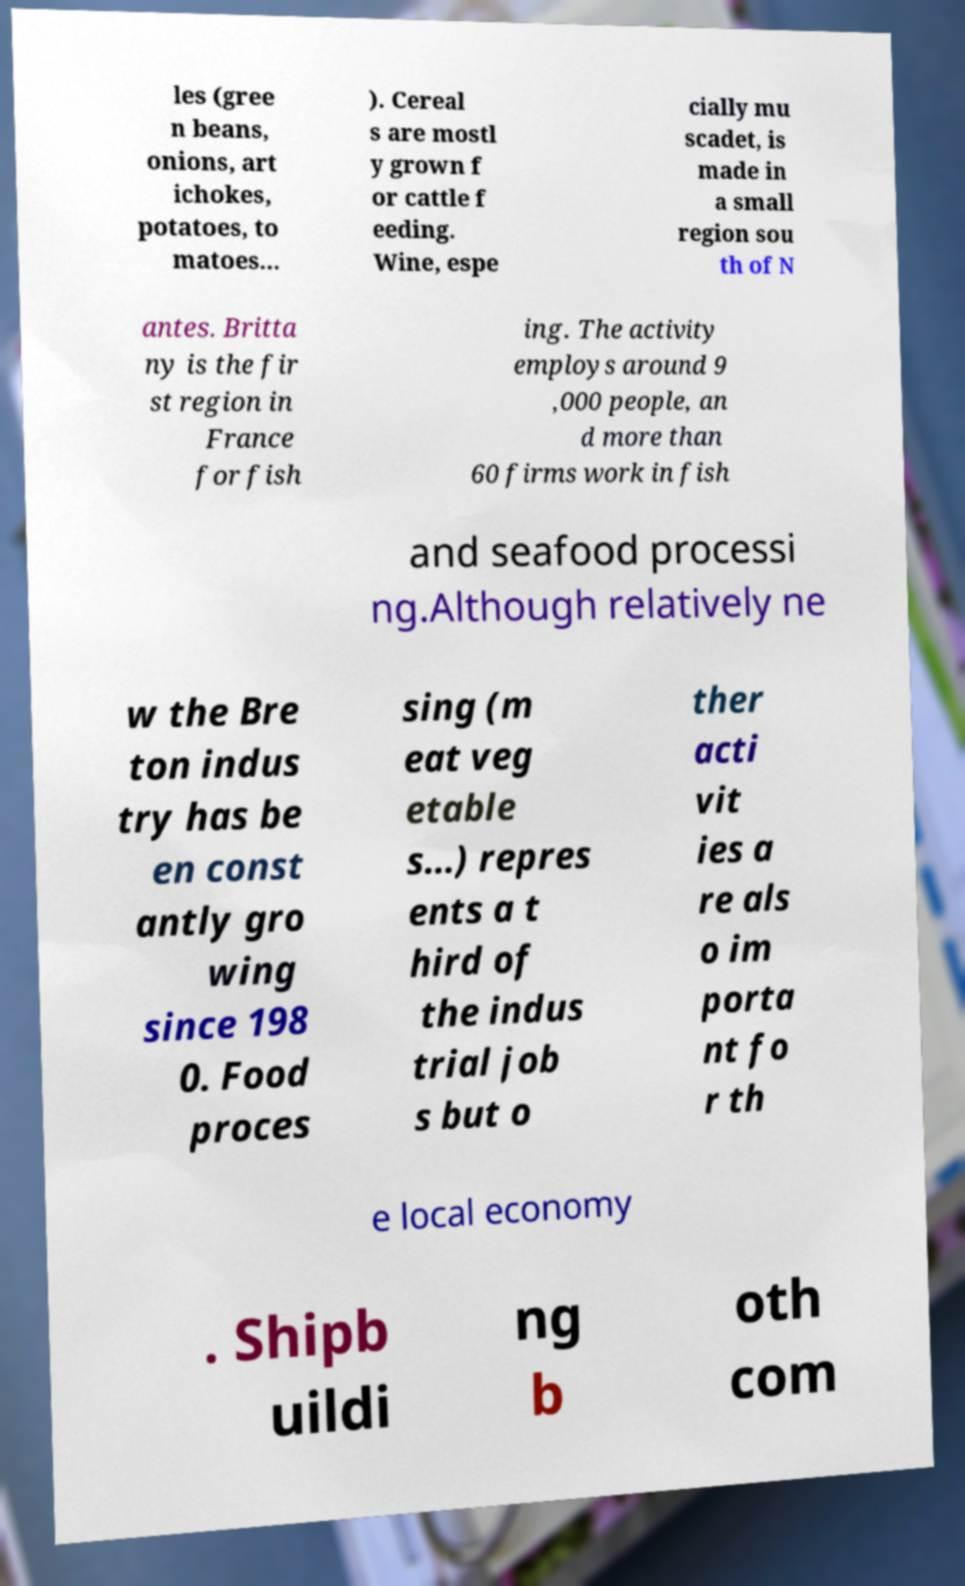Please identify and transcribe the text found in this image. les (gree n beans, onions, art ichokes, potatoes, to matoes... ). Cereal s are mostl y grown f or cattle f eeding. Wine, espe cially mu scadet, is made in a small region sou th of N antes. Britta ny is the fir st region in France for fish ing. The activity employs around 9 ,000 people, an d more than 60 firms work in fish and seafood processi ng.Although relatively ne w the Bre ton indus try has be en const antly gro wing since 198 0. Food proces sing (m eat veg etable s...) repres ents a t hird of the indus trial job s but o ther acti vit ies a re als o im porta nt fo r th e local economy . Shipb uildi ng b oth com 